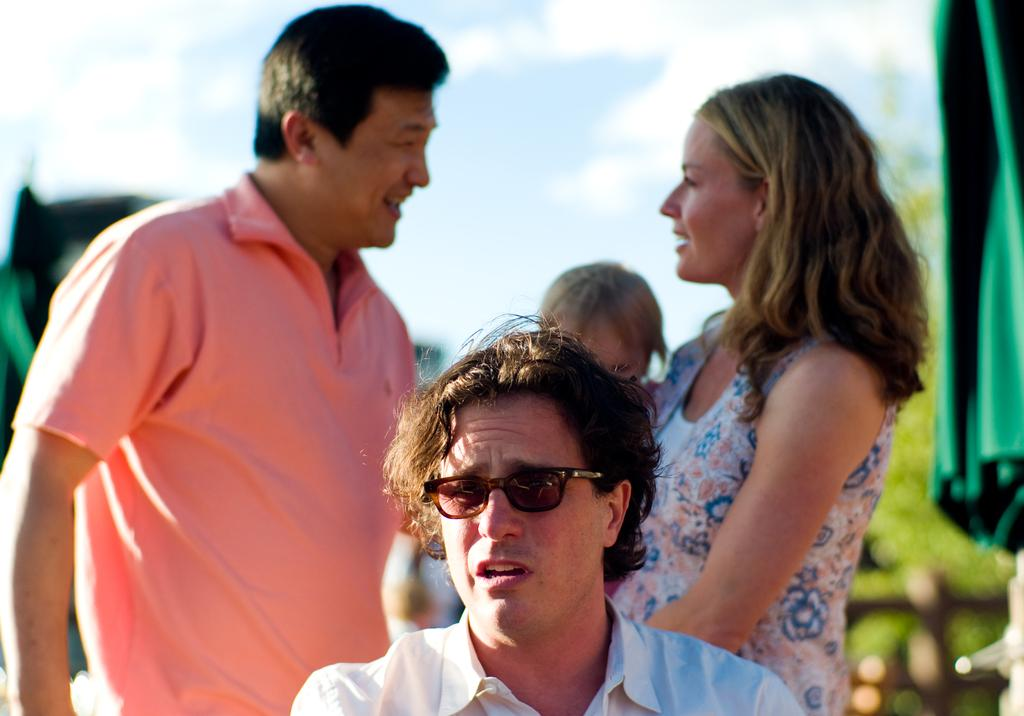How many people are in the image? There are four persons in the image. What can be seen in the background of the image? There is a sky visible in the background of the image. What is located on the right side of the image? There is a cloth on the right side of the image. How would you describe the background of the image? The background of the image is blurred. What type of plastic is used to make the salt shaker in the image? There is no salt shaker present in the image, so it is not possible to determine the type of plastic used. 